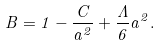<formula> <loc_0><loc_0><loc_500><loc_500>B = 1 - \frac { C } { a ^ { 2 } } + \frac { \Lambda } { 6 } a ^ { 2 } .</formula> 